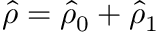Convert formula to latex. <formula><loc_0><loc_0><loc_500><loc_500>\hat { \rho } = \hat { \rho } _ { 0 } + \hat { \rho } _ { 1 }</formula> 